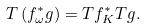<formula> <loc_0><loc_0><loc_500><loc_500>T \left ( f ^ { * } _ { \omega } g \right ) = T f ^ { * } _ { K } T g .</formula> 